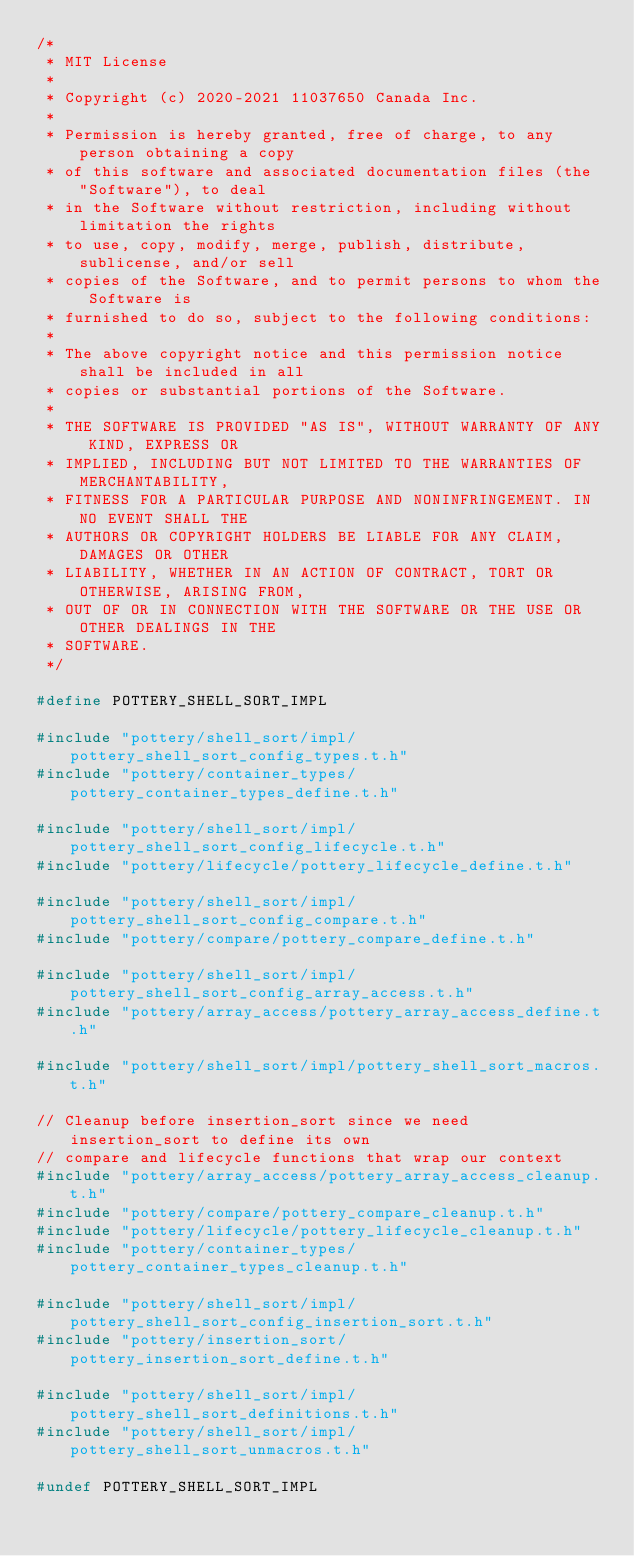<code> <loc_0><loc_0><loc_500><loc_500><_C_>/*
 * MIT License
 *
 * Copyright (c) 2020-2021 11037650 Canada Inc.
 *
 * Permission is hereby granted, free of charge, to any person obtaining a copy
 * of this software and associated documentation files (the "Software"), to deal
 * in the Software without restriction, including without limitation the rights
 * to use, copy, modify, merge, publish, distribute, sublicense, and/or sell
 * copies of the Software, and to permit persons to whom the Software is
 * furnished to do so, subject to the following conditions:
 *
 * The above copyright notice and this permission notice shall be included in all
 * copies or substantial portions of the Software.
 *
 * THE SOFTWARE IS PROVIDED "AS IS", WITHOUT WARRANTY OF ANY KIND, EXPRESS OR
 * IMPLIED, INCLUDING BUT NOT LIMITED TO THE WARRANTIES OF MERCHANTABILITY,
 * FITNESS FOR A PARTICULAR PURPOSE AND NONINFRINGEMENT. IN NO EVENT SHALL THE
 * AUTHORS OR COPYRIGHT HOLDERS BE LIABLE FOR ANY CLAIM, DAMAGES OR OTHER
 * LIABILITY, WHETHER IN AN ACTION OF CONTRACT, TORT OR OTHERWISE, ARISING FROM,
 * OUT OF OR IN CONNECTION WITH THE SOFTWARE OR THE USE OR OTHER DEALINGS IN THE
 * SOFTWARE.
 */

#define POTTERY_SHELL_SORT_IMPL

#include "pottery/shell_sort/impl/pottery_shell_sort_config_types.t.h"
#include "pottery/container_types/pottery_container_types_define.t.h"

#include "pottery/shell_sort/impl/pottery_shell_sort_config_lifecycle.t.h"
#include "pottery/lifecycle/pottery_lifecycle_define.t.h"

#include "pottery/shell_sort/impl/pottery_shell_sort_config_compare.t.h"
#include "pottery/compare/pottery_compare_define.t.h"

#include "pottery/shell_sort/impl/pottery_shell_sort_config_array_access.t.h"
#include "pottery/array_access/pottery_array_access_define.t.h"

#include "pottery/shell_sort/impl/pottery_shell_sort_macros.t.h"

// Cleanup before insertion_sort since we need insertion_sort to define its own
// compare and lifecycle functions that wrap our context
#include "pottery/array_access/pottery_array_access_cleanup.t.h"
#include "pottery/compare/pottery_compare_cleanup.t.h"
#include "pottery/lifecycle/pottery_lifecycle_cleanup.t.h"
#include "pottery/container_types/pottery_container_types_cleanup.t.h"

#include "pottery/shell_sort/impl/pottery_shell_sort_config_insertion_sort.t.h"
#include "pottery/insertion_sort/pottery_insertion_sort_define.t.h"

#include "pottery/shell_sort/impl/pottery_shell_sort_definitions.t.h"
#include "pottery/shell_sort/impl/pottery_shell_sort_unmacros.t.h"

#undef POTTERY_SHELL_SORT_IMPL
</code> 